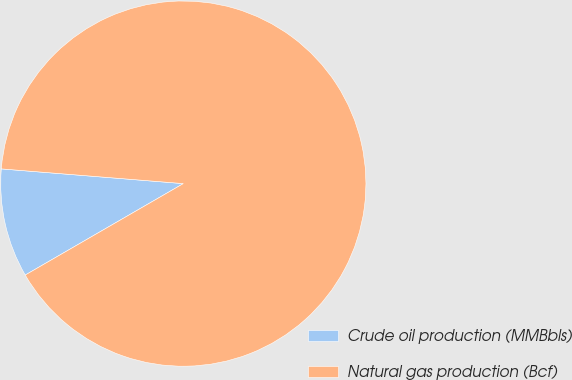Convert chart to OTSL. <chart><loc_0><loc_0><loc_500><loc_500><pie_chart><fcel>Crude oil production (MMBbls)<fcel>Natural gas production (Bcf)<nl><fcel>9.63%<fcel>90.37%<nl></chart> 